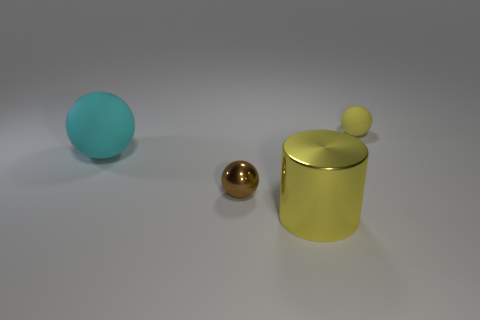Are there more small spheres in front of the cyan sphere than large gray cylinders?
Give a very brief answer. Yes. Are the yellow thing behind the big cylinder and the brown thing made of the same material?
Provide a succinct answer. No. There is a matte object left of the sphere that is behind the cyan ball that is to the left of the large yellow metal object; what size is it?
Your response must be concise. Large. What size is the other object that is made of the same material as the small brown thing?
Ensure brevity in your answer.  Large. There is a thing that is both to the right of the brown metallic object and behind the big yellow metal thing; what is its color?
Your response must be concise. Yellow. There is a yellow thing behind the brown metal thing; is its shape the same as the matte thing that is left of the small yellow sphere?
Your answer should be very brief. Yes. There is a object behind the cyan matte sphere; what is its material?
Provide a succinct answer. Rubber. What size is the matte thing that is the same color as the cylinder?
Offer a very short reply. Small. How many objects are either rubber objects on the left side of the brown metallic thing or tiny yellow metallic balls?
Provide a succinct answer. 1. Are there an equal number of brown things that are in front of the yellow rubber object and green metallic balls?
Keep it short and to the point. No. 